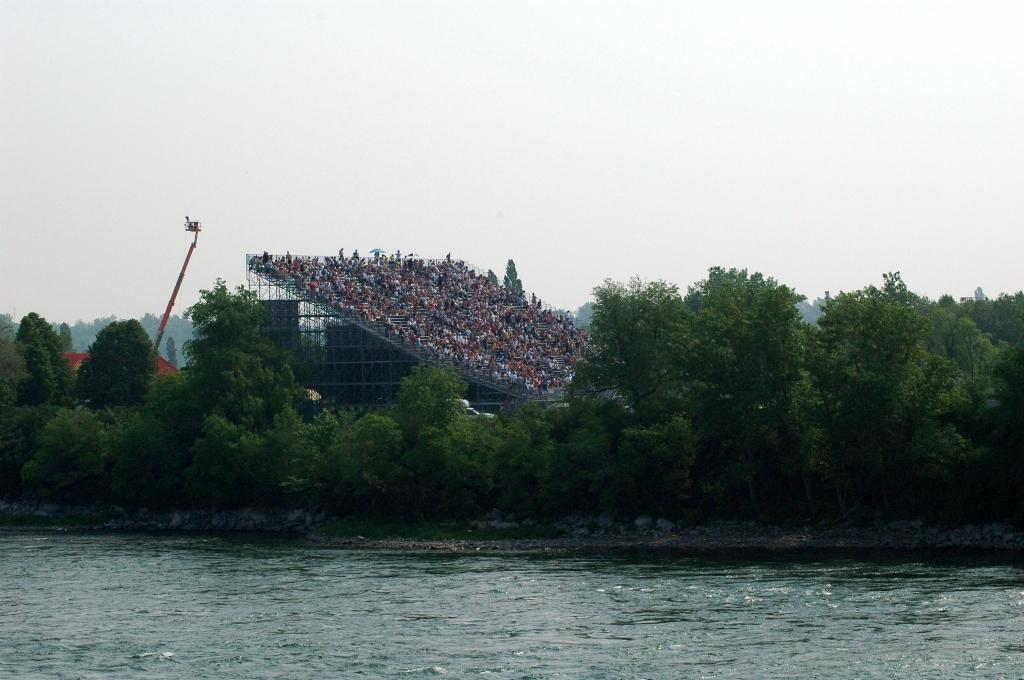What is the main element in the image? There is water in the image. What type of vegetation can be seen in the image? There are green trees in the image. What structure is present in the image? There is a crane in the image. What is visible at the top of the image? The sky is visible at the top of the image. Where is the market located in the image? There is no market present in the image. What color is the wrist of the person in the image? There is no person present in the image, so it is not possible to determine the color of their wrist. 